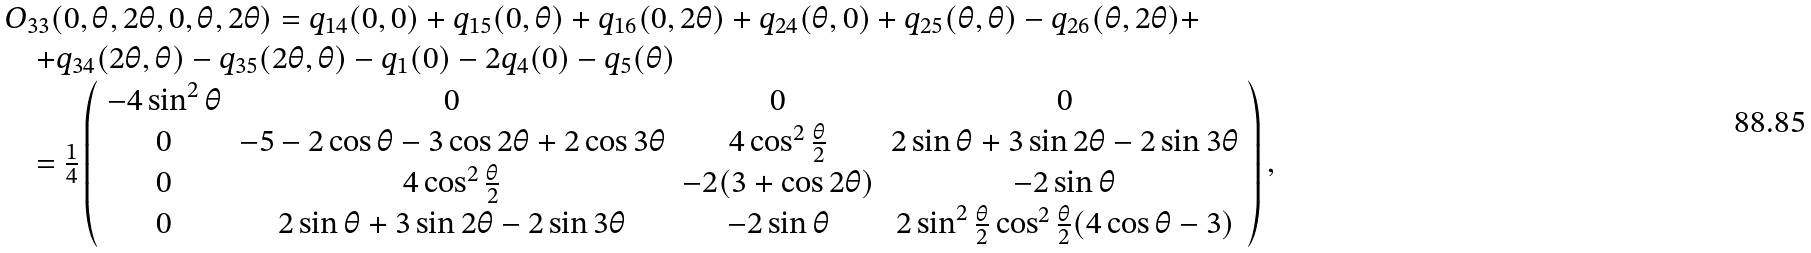Convert formula to latex. <formula><loc_0><loc_0><loc_500><loc_500>\begin{array} { l l l } & O _ { 3 3 } ( 0 , \theta , 2 \theta , 0 , \theta , 2 \theta ) = q _ { 1 4 } ( 0 , 0 ) + q _ { 1 5 } ( 0 , \theta ) + q _ { 1 6 } ( 0 , 2 \theta ) + q _ { 2 4 } ( \theta , 0 ) + q _ { 2 5 } ( \theta , \theta ) - q _ { 2 6 } ( \theta , 2 \theta ) + \\ & \quad + q _ { 3 4 } ( 2 \theta , \theta ) - q _ { 3 5 } ( 2 \theta , \theta ) - q _ { 1 } ( 0 ) - 2 q _ { 4 } ( 0 ) - q _ { 5 } ( \theta ) \\ & \quad = \frac { 1 } { 4 } \left ( \begin{array} { c c c c } - 4 \sin ^ { 2 } \theta & 0 & 0 & 0 \\ 0 & - 5 - 2 \cos \theta - 3 \cos 2 \theta + 2 \cos 3 \theta & 4 \cos ^ { 2 } \frac { \theta } { 2 } & 2 \sin \theta + 3 \sin 2 \theta - 2 \sin 3 \theta \\ 0 & 4 \cos ^ { 2 } \frac { \theta } { 2 } & - 2 ( 3 + \cos 2 \theta ) & - 2 \sin \theta \\ 0 & 2 \sin \theta + 3 \sin 2 \theta - 2 \sin 3 \theta & - 2 \sin \theta & 2 \sin ^ { 2 } \frac { \theta } { 2 } \cos ^ { 2 } \frac { \theta } { 2 } ( 4 \cos \theta - 3 ) \end{array} \right ) , \end{array}</formula> 